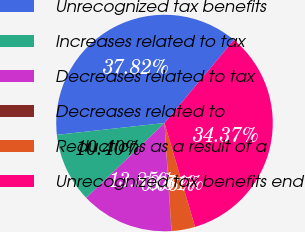Convert chart to OTSL. <chart><loc_0><loc_0><loc_500><loc_500><pie_chart><fcel>Unrecognized tax benefits<fcel>Increases related to tax<fcel>Decreases related to tax<fcel>Decreases related to<fcel>Reductions as a result of a<fcel>Unrecognized tax benefits end<nl><fcel>37.82%<fcel>10.4%<fcel>13.85%<fcel>0.06%<fcel>3.51%<fcel>34.37%<nl></chart> 